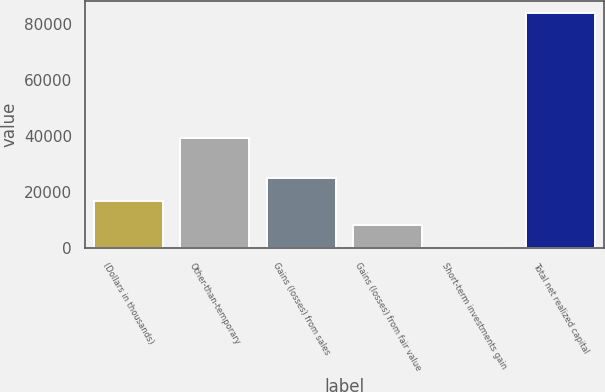<chart> <loc_0><loc_0><loc_500><loc_500><bar_chart><fcel>(Dollars in thousands)<fcel>Other-than-temporary<fcel>Gains (losses) from sales<fcel>Gains (losses) from fair value<fcel>Short-term investments gain<fcel>Total net realized capital<nl><fcel>16811.6<fcel>39502<fcel>25215.9<fcel>8407.3<fcel>3<fcel>84046<nl></chart> 